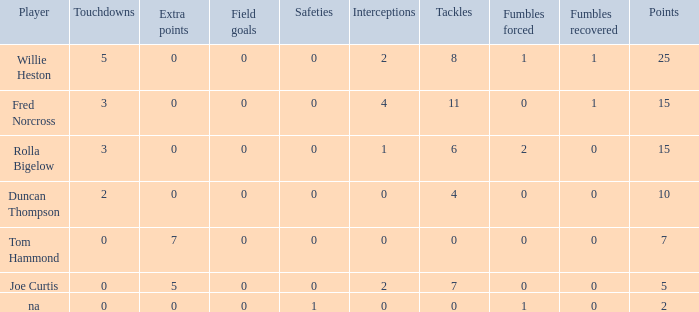Which Points is the lowest one that has Touchdowns smaller than 2, and an Extra points of 7, and a Field goals smaller than 0? None. 